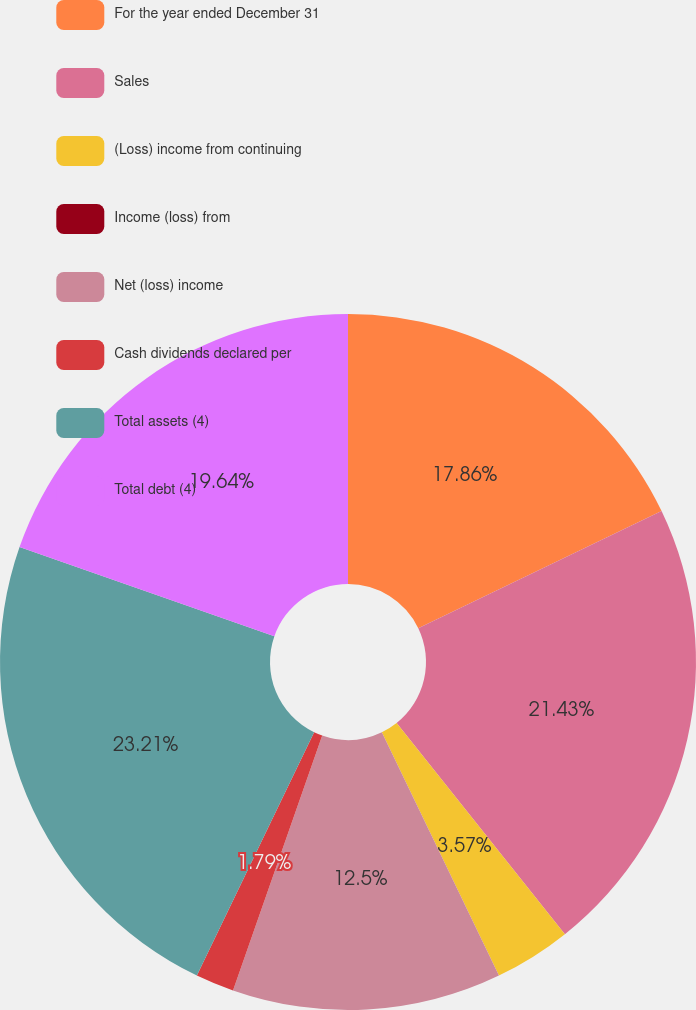Convert chart to OTSL. <chart><loc_0><loc_0><loc_500><loc_500><pie_chart><fcel>For the year ended December 31<fcel>Sales<fcel>(Loss) income from continuing<fcel>Income (loss) from<fcel>Net (loss) income<fcel>Cash dividends declared per<fcel>Total assets (4)<fcel>Total debt (4)<nl><fcel>17.86%<fcel>21.43%<fcel>3.57%<fcel>0.0%<fcel>12.5%<fcel>1.79%<fcel>23.21%<fcel>19.64%<nl></chart> 